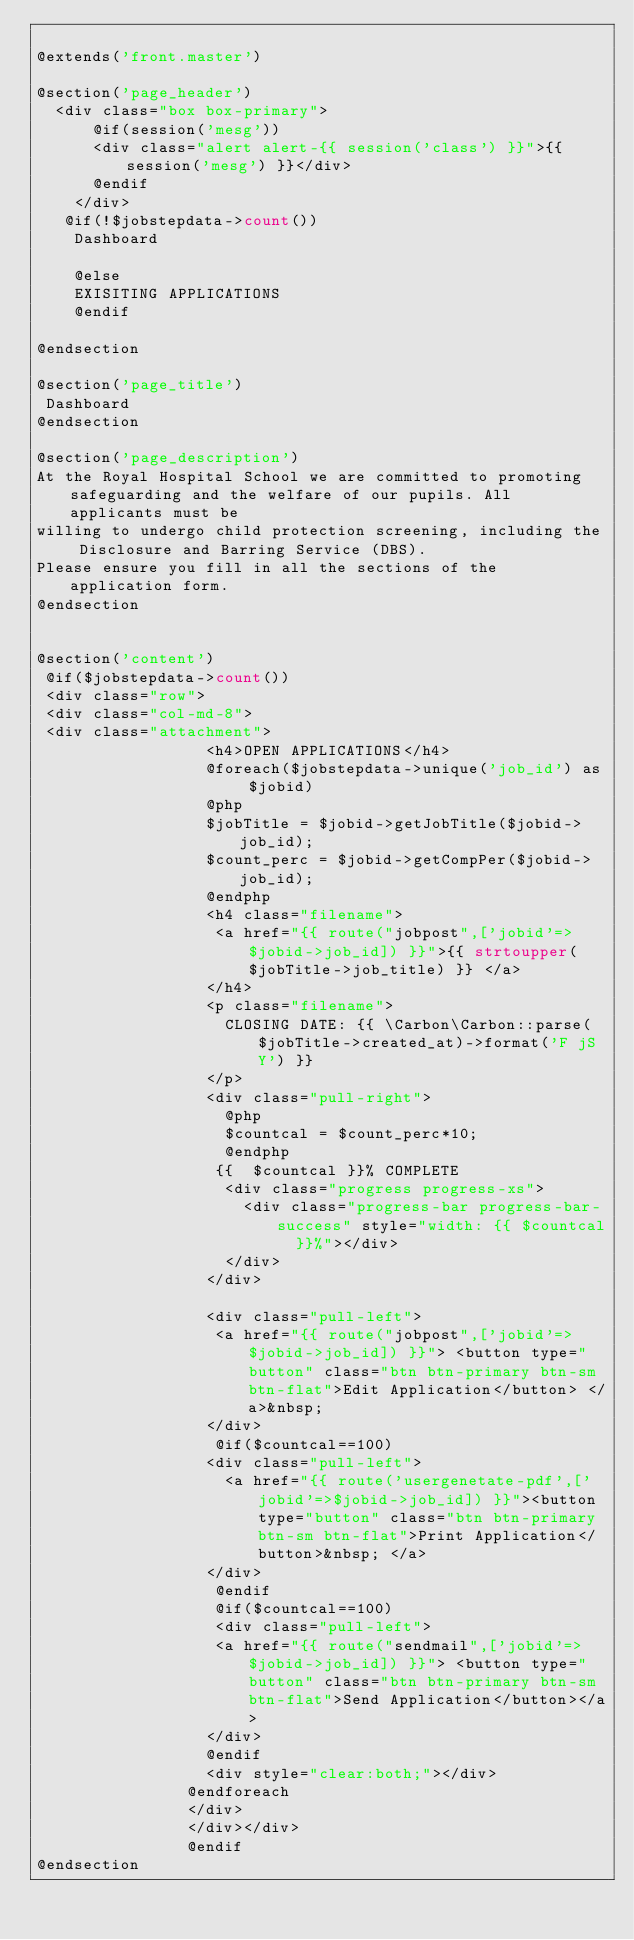Convert code to text. <code><loc_0><loc_0><loc_500><loc_500><_PHP_>
@extends('front.master')

@section('page_header')
  <div class="box box-primary">
      @if(session('mesg'))
      <div class="alert alert-{{ session('class') }}">{{ session('mesg') }}</div>
      @endif 
    </div>
   @if(!$jobstepdata->count())
    Dashboard 
     
    @else
    EXISITING APPLICATIONS
    @endif
 
@endsection

@section('page_title')
 Dashboard
@endsection

@section('page_description')
At the Royal Hospital School we are committed to promoting safeguarding and the welfare of our pupils. All applicants must be
willing to undergo child protection screening, including the Disclosure and Barring Service (DBS).
Please ensure you fill in all the sections of the application form.
@endsection


@section('content')
 @if($jobstepdata->count())
 <div class="row">
 <div class="col-md-8">
 <div class="attachment">
                  <h4>OPEN APPLICATIONS</h4>
                  @foreach($jobstepdata->unique('job_id') as $jobid)
                  @php
                  $jobTitle = $jobid->getJobTitle($jobid->job_id);
                  $count_perc = $jobid->getCompPer($jobid->job_id);
                  @endphp
                  <h4 class="filename">
                   <a href="{{ route("jobpost",['jobid'=>$jobid->job_id]) }}">{{ strtoupper($jobTitle->job_title) }} </a>
                  </h4>
                  <p class="filename">
                    CLOSING DATE: {{ \Carbon\Carbon::parse($jobTitle->created_at)->format('F jS Y') }}
                  </p>
                  <div class="pull-right">
                    @php 
                    $countcal = $count_perc*10;
                    @endphp
                   {{  $countcal }}% COMPLETE
                    <div class="progress progress-xs">
                      <div class="progress-bar progress-bar-success" style="width: {{ $countcal  }}%"></div>
                    </div>
                  </div>

                  <div class="pull-left">
                   <a href="{{ route("jobpost",['jobid'=>$jobid->job_id]) }}"> <button type="button" class="btn btn-primary btn-sm btn-flat">Edit Application</button> </a>&nbsp;
                  </div>
                   @if($countcal==100)
                  <div class="pull-left">
                    <a href="{{ route('usergenetate-pdf',['jobid'=>$jobid->job_id]) }}"><button type="button" class="btn btn-primary btn-sm btn-flat">Print Application</button>&nbsp; </a>
                  </div>
                   @endif
                   @if($countcal==100)
                   <div class="pull-left">
                   <a href="{{ route("sendmail",['jobid'=>$jobid->job_id]) }}"> <button type="button" class="btn btn-primary btn-sm btn-flat">Send Application</button></a>
                  </div>
                  @endif
                  <div style="clear:both;"></div>
                @endforeach
                </div>
                </div></div>
                @endif
@endsection
</code> 